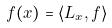Convert formula to latex. <formula><loc_0><loc_0><loc_500><loc_500>f ( x ) = \langle L _ { x } , f \rangle</formula> 